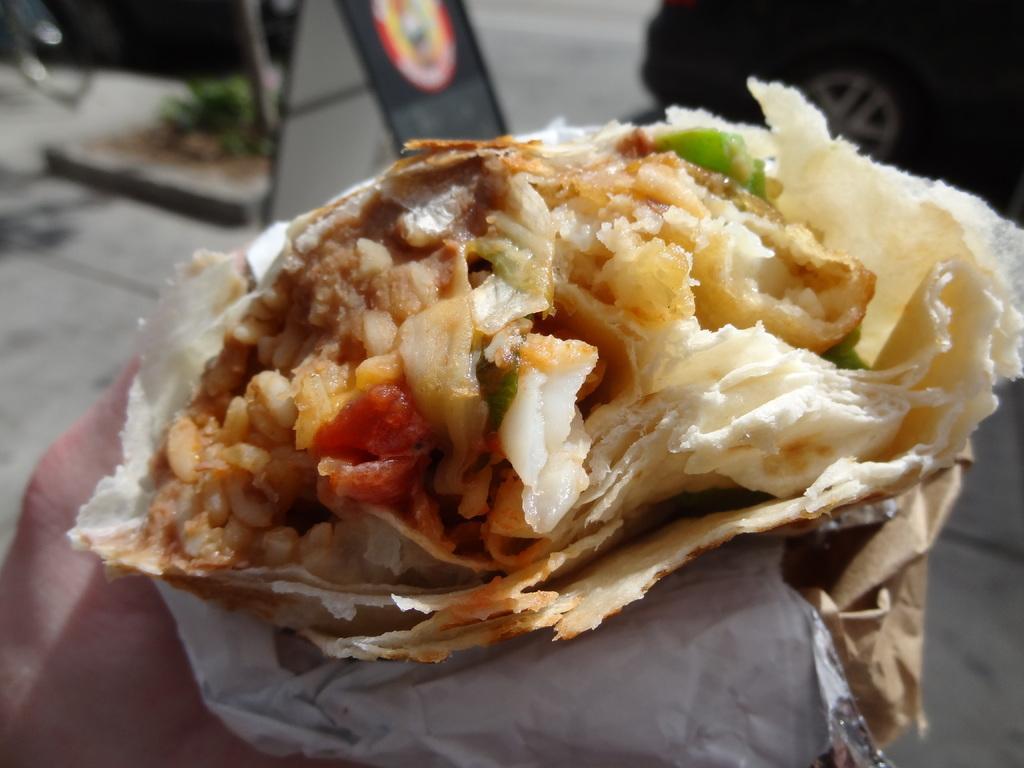In one or two sentences, can you explain what this image depicts? In this image I can see a food item which is brown, red, cream and green in color in a tissue paper and I can see a person is holding this food item. In the background I can see the floor, a plant, few vehicles on the road and a black colored board. 